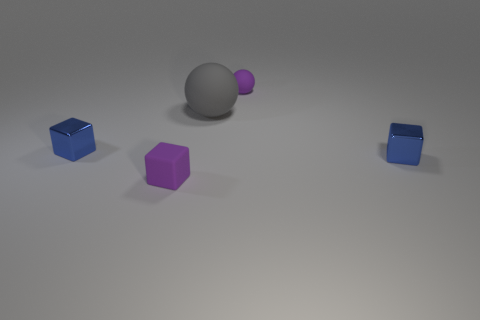What number of other balls are the same color as the big rubber sphere?
Your answer should be very brief. 0. There is a purple thing that is the same size as the purple sphere; what is its shape?
Make the answer very short. Cube. Are there any cubes in front of the tiny purple block?
Ensure brevity in your answer.  No. Does the gray thing have the same size as the purple rubber sphere?
Keep it short and to the point. No. There is a purple matte thing that is on the left side of the gray sphere; what is its shape?
Provide a succinct answer. Cube. Are there any gray balls of the same size as the purple rubber sphere?
Your answer should be very brief. No. What material is the purple thing that is the same size as the purple rubber block?
Provide a succinct answer. Rubber. There is a rubber object left of the gray rubber thing; what is its size?
Provide a succinct answer. Small. The purple matte sphere has what size?
Offer a terse response. Small. There is a gray rubber ball; is its size the same as the metal thing that is to the left of the small matte sphere?
Provide a short and direct response. No. 